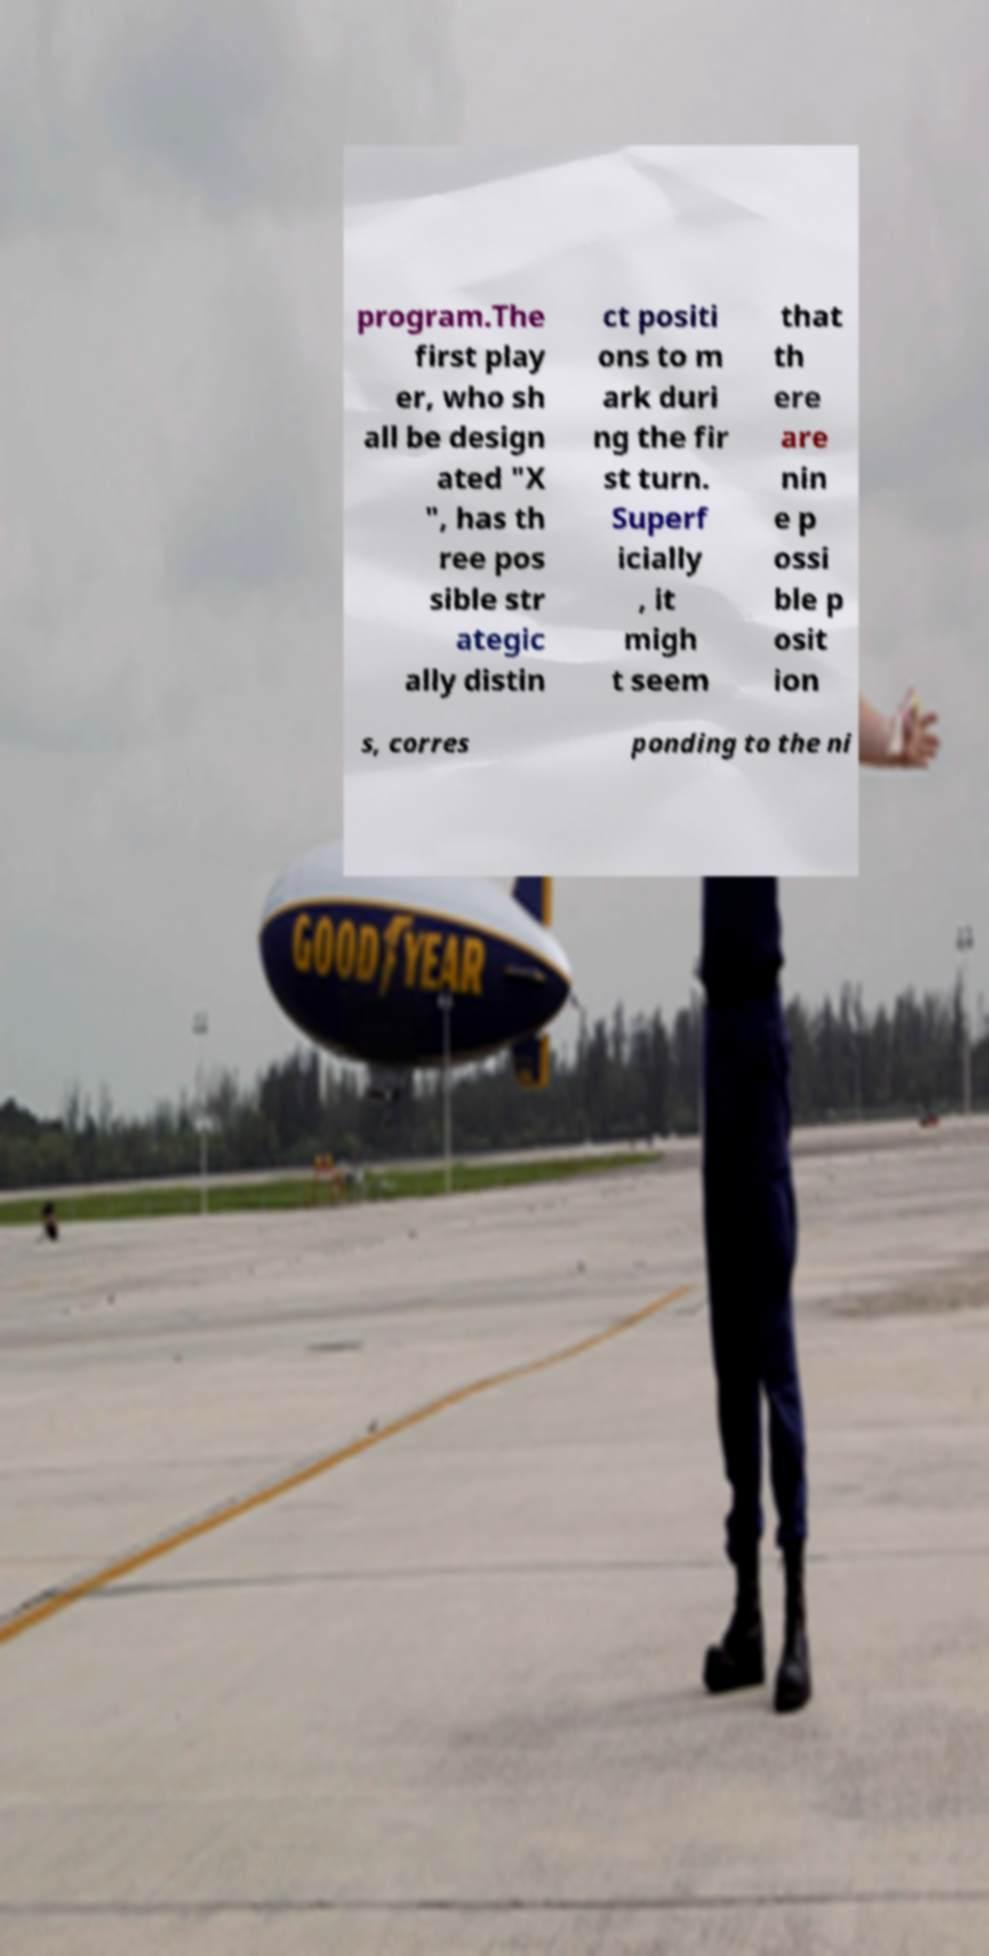Can you read and provide the text displayed in the image?This photo seems to have some interesting text. Can you extract and type it out for me? program.The first play er, who sh all be design ated "X ", has th ree pos sible str ategic ally distin ct positi ons to m ark duri ng the fir st turn. Superf icially , it migh t seem that th ere are nin e p ossi ble p osit ion s, corres ponding to the ni 